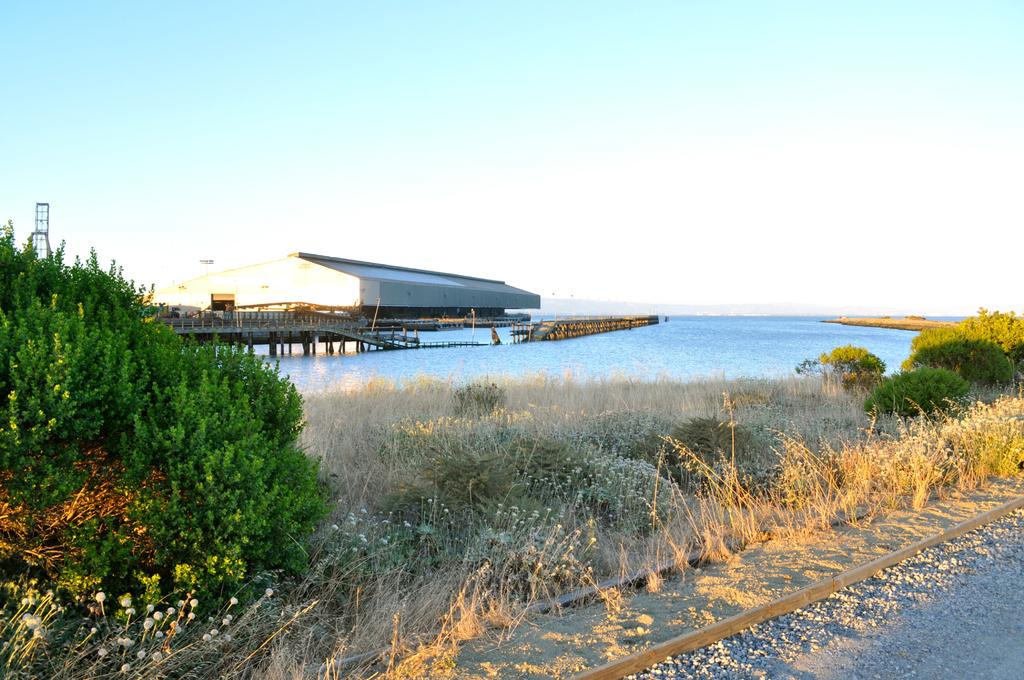What type of vegetation is present at the bottom of the image? There is grass and bushes at the bottom of the image. What can be found at the bottom of the image alongside the vegetation? There is a railway track at the bottom of the image. What is located in the middle of the image? There is water, a bridge, and a house in the middle of the image. What is the sky's condition in the image? The sky is visible at the top of the image. What type of thing is the angle used for in the image? There is no mention of an angle in the image, so it cannot be used for anything. Can you tell me how many requests are visible in the image? There is no mention of a request in the image, so it cannot be counted. 